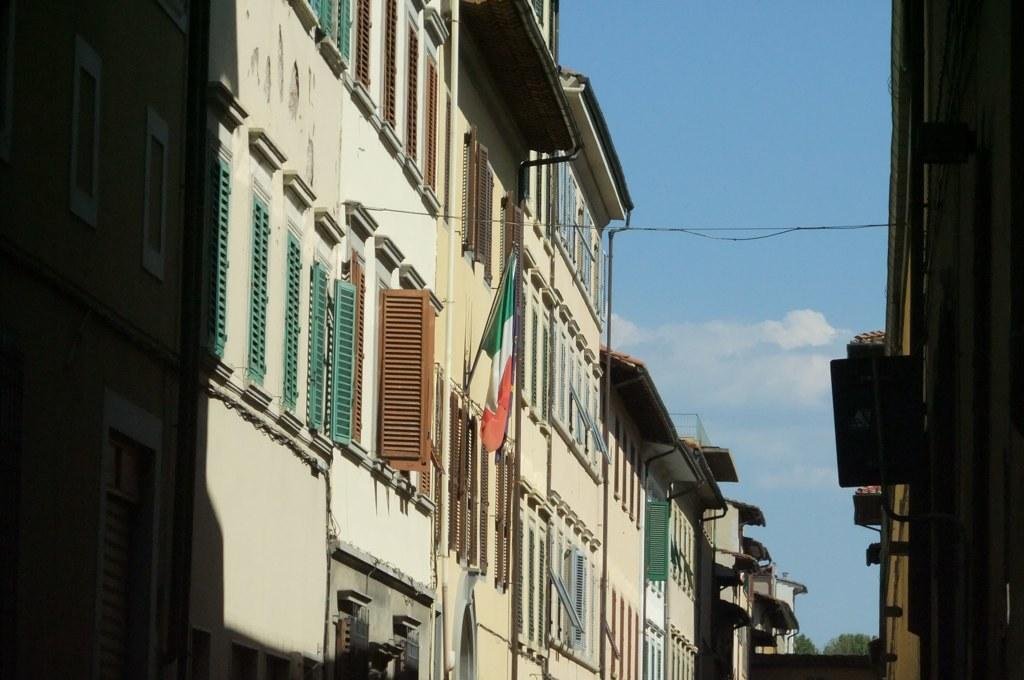What can be seen on both sides of the image? There are buildings on both sides of the image. What feature do the buildings have? The buildings have windows. Is there any symbol or emblem visible on one of the buildings? Yes, there is a flag with a pole on one of the buildings. What is visible in the background of the image? The sky is visible in the background of the image. What can be observed about the sky in the image? There are clouds in the sky. How many girls are playing with cats in the image? There are no girls or cats present in the image; it features buildings with windows, a flag, and a sky with clouds. 